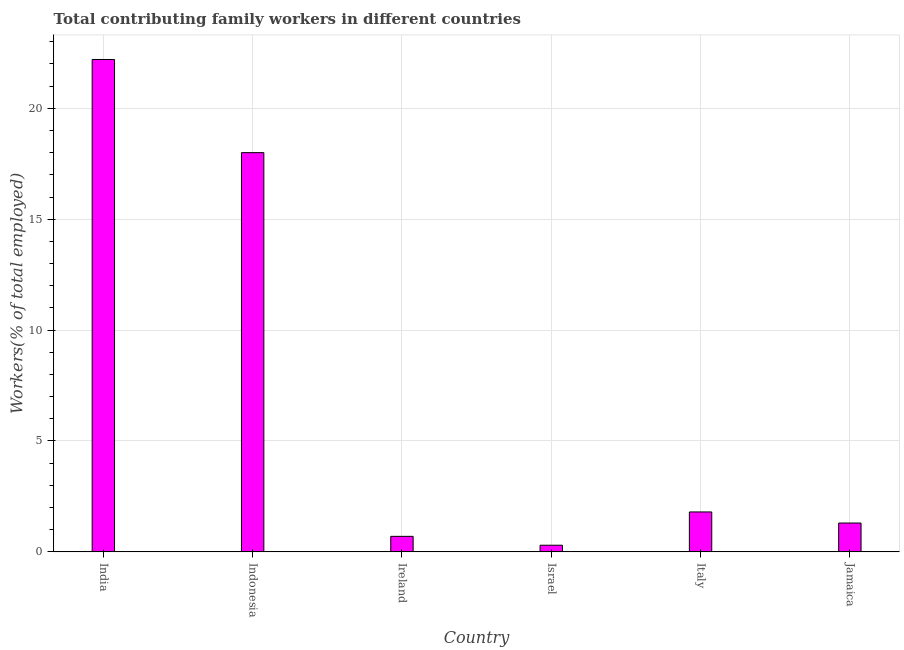Does the graph contain grids?
Keep it short and to the point. Yes. What is the title of the graph?
Give a very brief answer. Total contributing family workers in different countries. What is the label or title of the Y-axis?
Provide a short and direct response. Workers(% of total employed). What is the contributing family workers in Italy?
Offer a terse response. 1.8. Across all countries, what is the maximum contributing family workers?
Provide a succinct answer. 22.2. Across all countries, what is the minimum contributing family workers?
Provide a short and direct response. 0.3. In which country was the contributing family workers maximum?
Make the answer very short. India. In which country was the contributing family workers minimum?
Your response must be concise. Israel. What is the sum of the contributing family workers?
Your answer should be compact. 44.3. What is the difference between the contributing family workers in India and Israel?
Offer a very short reply. 21.9. What is the average contributing family workers per country?
Your answer should be compact. 7.38. What is the median contributing family workers?
Your answer should be compact. 1.55. In how many countries, is the contributing family workers greater than 16 %?
Make the answer very short. 2. What is the ratio of the contributing family workers in Indonesia to that in Jamaica?
Your answer should be compact. 13.85. Is the difference between the contributing family workers in Ireland and Italy greater than the difference between any two countries?
Offer a terse response. No. Is the sum of the contributing family workers in India and Indonesia greater than the maximum contributing family workers across all countries?
Keep it short and to the point. Yes. What is the difference between the highest and the lowest contributing family workers?
Give a very brief answer. 21.9. In how many countries, is the contributing family workers greater than the average contributing family workers taken over all countries?
Make the answer very short. 2. How many bars are there?
Provide a succinct answer. 6. Are all the bars in the graph horizontal?
Your response must be concise. No. How many countries are there in the graph?
Give a very brief answer. 6. Are the values on the major ticks of Y-axis written in scientific E-notation?
Offer a terse response. No. What is the Workers(% of total employed) in India?
Provide a short and direct response. 22.2. What is the Workers(% of total employed) of Indonesia?
Provide a short and direct response. 18. What is the Workers(% of total employed) of Ireland?
Your answer should be very brief. 0.7. What is the Workers(% of total employed) in Israel?
Your answer should be compact. 0.3. What is the Workers(% of total employed) of Italy?
Ensure brevity in your answer.  1.8. What is the Workers(% of total employed) of Jamaica?
Keep it short and to the point. 1.3. What is the difference between the Workers(% of total employed) in India and Israel?
Provide a short and direct response. 21.9. What is the difference between the Workers(% of total employed) in India and Italy?
Offer a terse response. 20.4. What is the difference between the Workers(% of total employed) in India and Jamaica?
Your answer should be very brief. 20.9. What is the difference between the Workers(% of total employed) in Indonesia and Israel?
Give a very brief answer. 17.7. What is the difference between the Workers(% of total employed) in Indonesia and Italy?
Ensure brevity in your answer.  16.2. What is the difference between the Workers(% of total employed) in Ireland and Italy?
Give a very brief answer. -1.1. What is the difference between the Workers(% of total employed) in Ireland and Jamaica?
Provide a succinct answer. -0.6. What is the difference between the Workers(% of total employed) in Israel and Jamaica?
Give a very brief answer. -1. What is the ratio of the Workers(% of total employed) in India to that in Indonesia?
Give a very brief answer. 1.23. What is the ratio of the Workers(% of total employed) in India to that in Ireland?
Provide a succinct answer. 31.71. What is the ratio of the Workers(% of total employed) in India to that in Israel?
Offer a very short reply. 74. What is the ratio of the Workers(% of total employed) in India to that in Italy?
Provide a short and direct response. 12.33. What is the ratio of the Workers(% of total employed) in India to that in Jamaica?
Your answer should be compact. 17.08. What is the ratio of the Workers(% of total employed) in Indonesia to that in Ireland?
Give a very brief answer. 25.71. What is the ratio of the Workers(% of total employed) in Indonesia to that in Italy?
Give a very brief answer. 10. What is the ratio of the Workers(% of total employed) in Indonesia to that in Jamaica?
Your answer should be very brief. 13.85. What is the ratio of the Workers(% of total employed) in Ireland to that in Israel?
Your answer should be compact. 2.33. What is the ratio of the Workers(% of total employed) in Ireland to that in Italy?
Ensure brevity in your answer.  0.39. What is the ratio of the Workers(% of total employed) in Ireland to that in Jamaica?
Your answer should be compact. 0.54. What is the ratio of the Workers(% of total employed) in Israel to that in Italy?
Your answer should be very brief. 0.17. What is the ratio of the Workers(% of total employed) in Israel to that in Jamaica?
Ensure brevity in your answer.  0.23. What is the ratio of the Workers(% of total employed) in Italy to that in Jamaica?
Offer a very short reply. 1.39. 